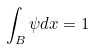Convert formula to latex. <formula><loc_0><loc_0><loc_500><loc_500>\int _ { B } \psi d x = 1</formula> 